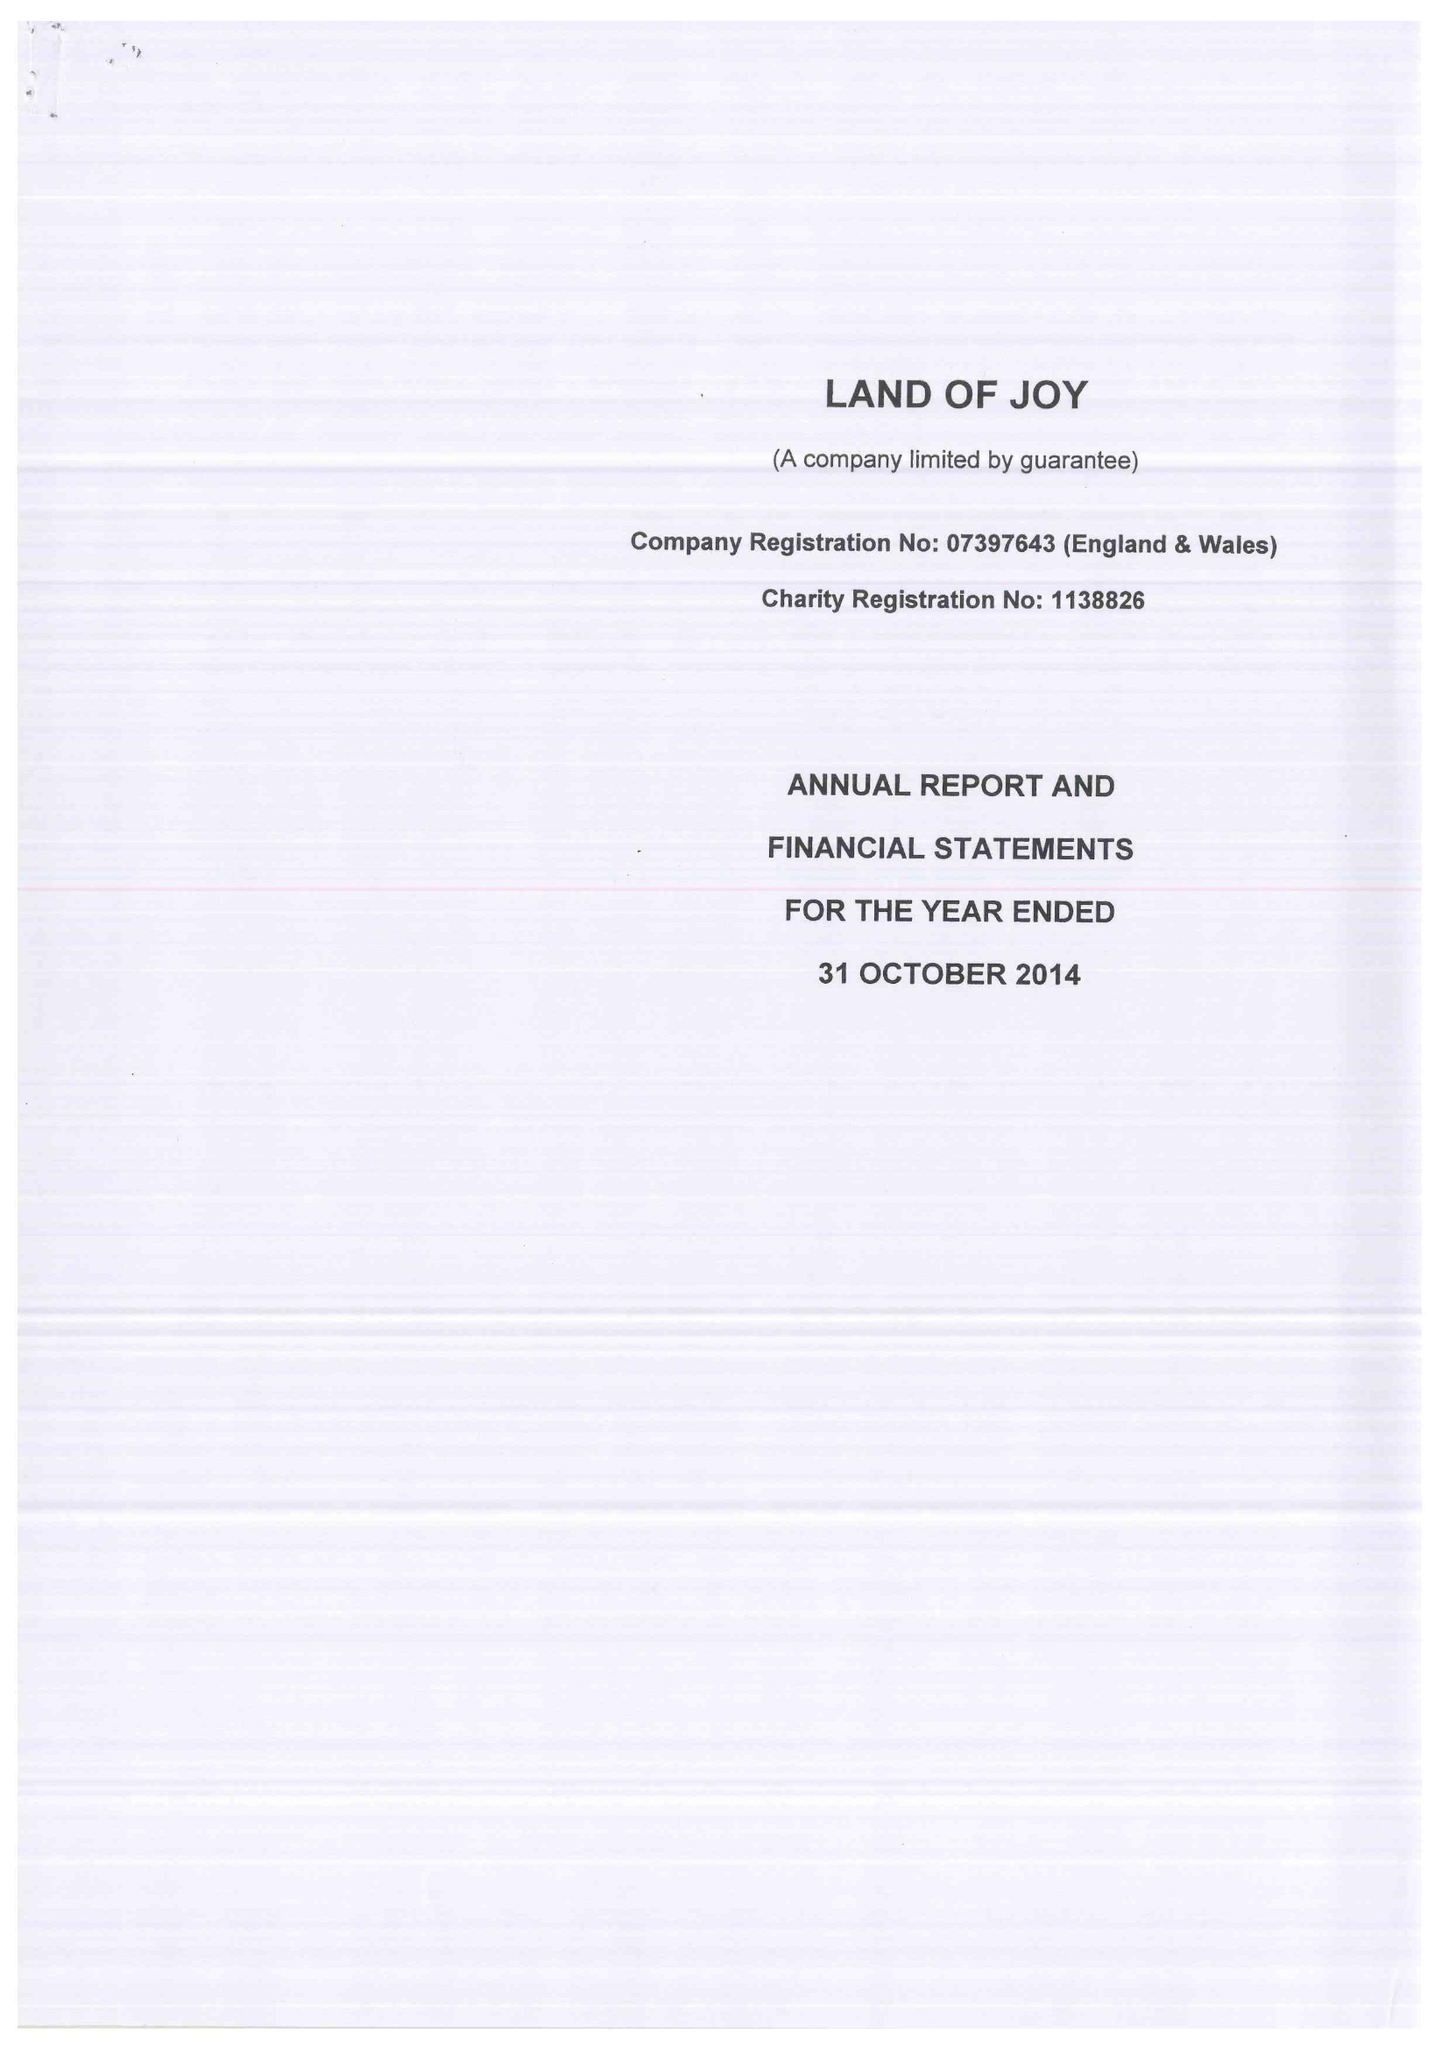What is the value for the spending_annually_in_british_pounds?
Answer the question using a single word or phrase. 7925.00 